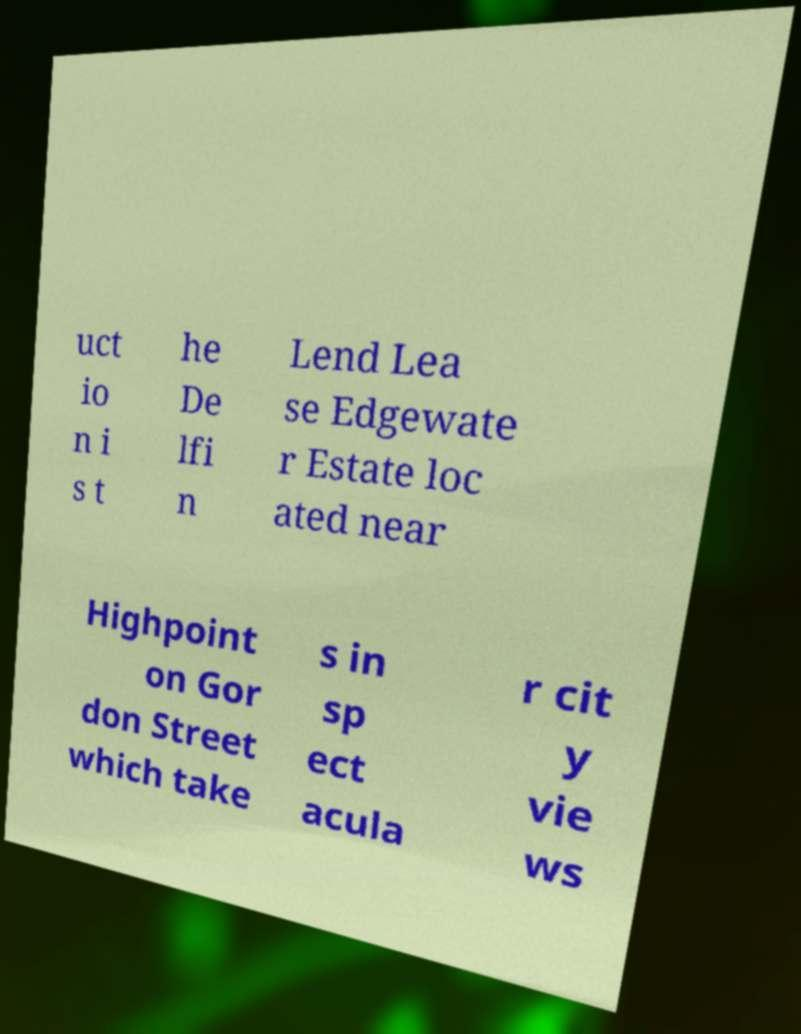What messages or text are displayed in this image? I need them in a readable, typed format. uct io n i s t he De lfi n Lend Lea se Edgewate r Estate loc ated near Highpoint on Gor don Street which take s in sp ect acula r cit y vie ws 